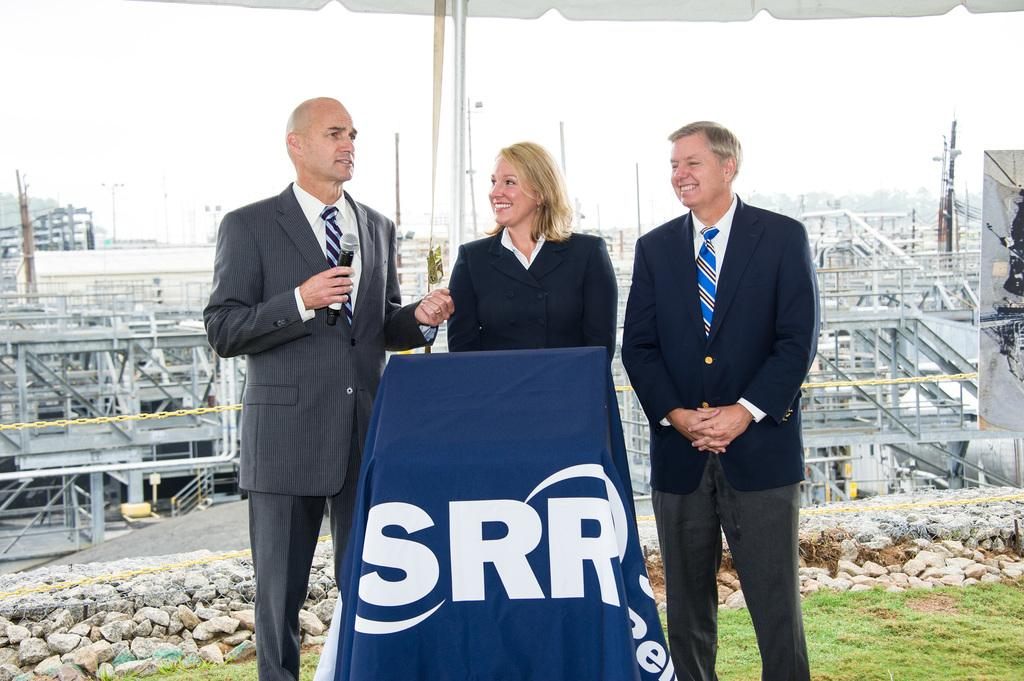Provide a one-sentence caption for the provided image. Two men and a woman stand behind a podium with SRR across the front. 